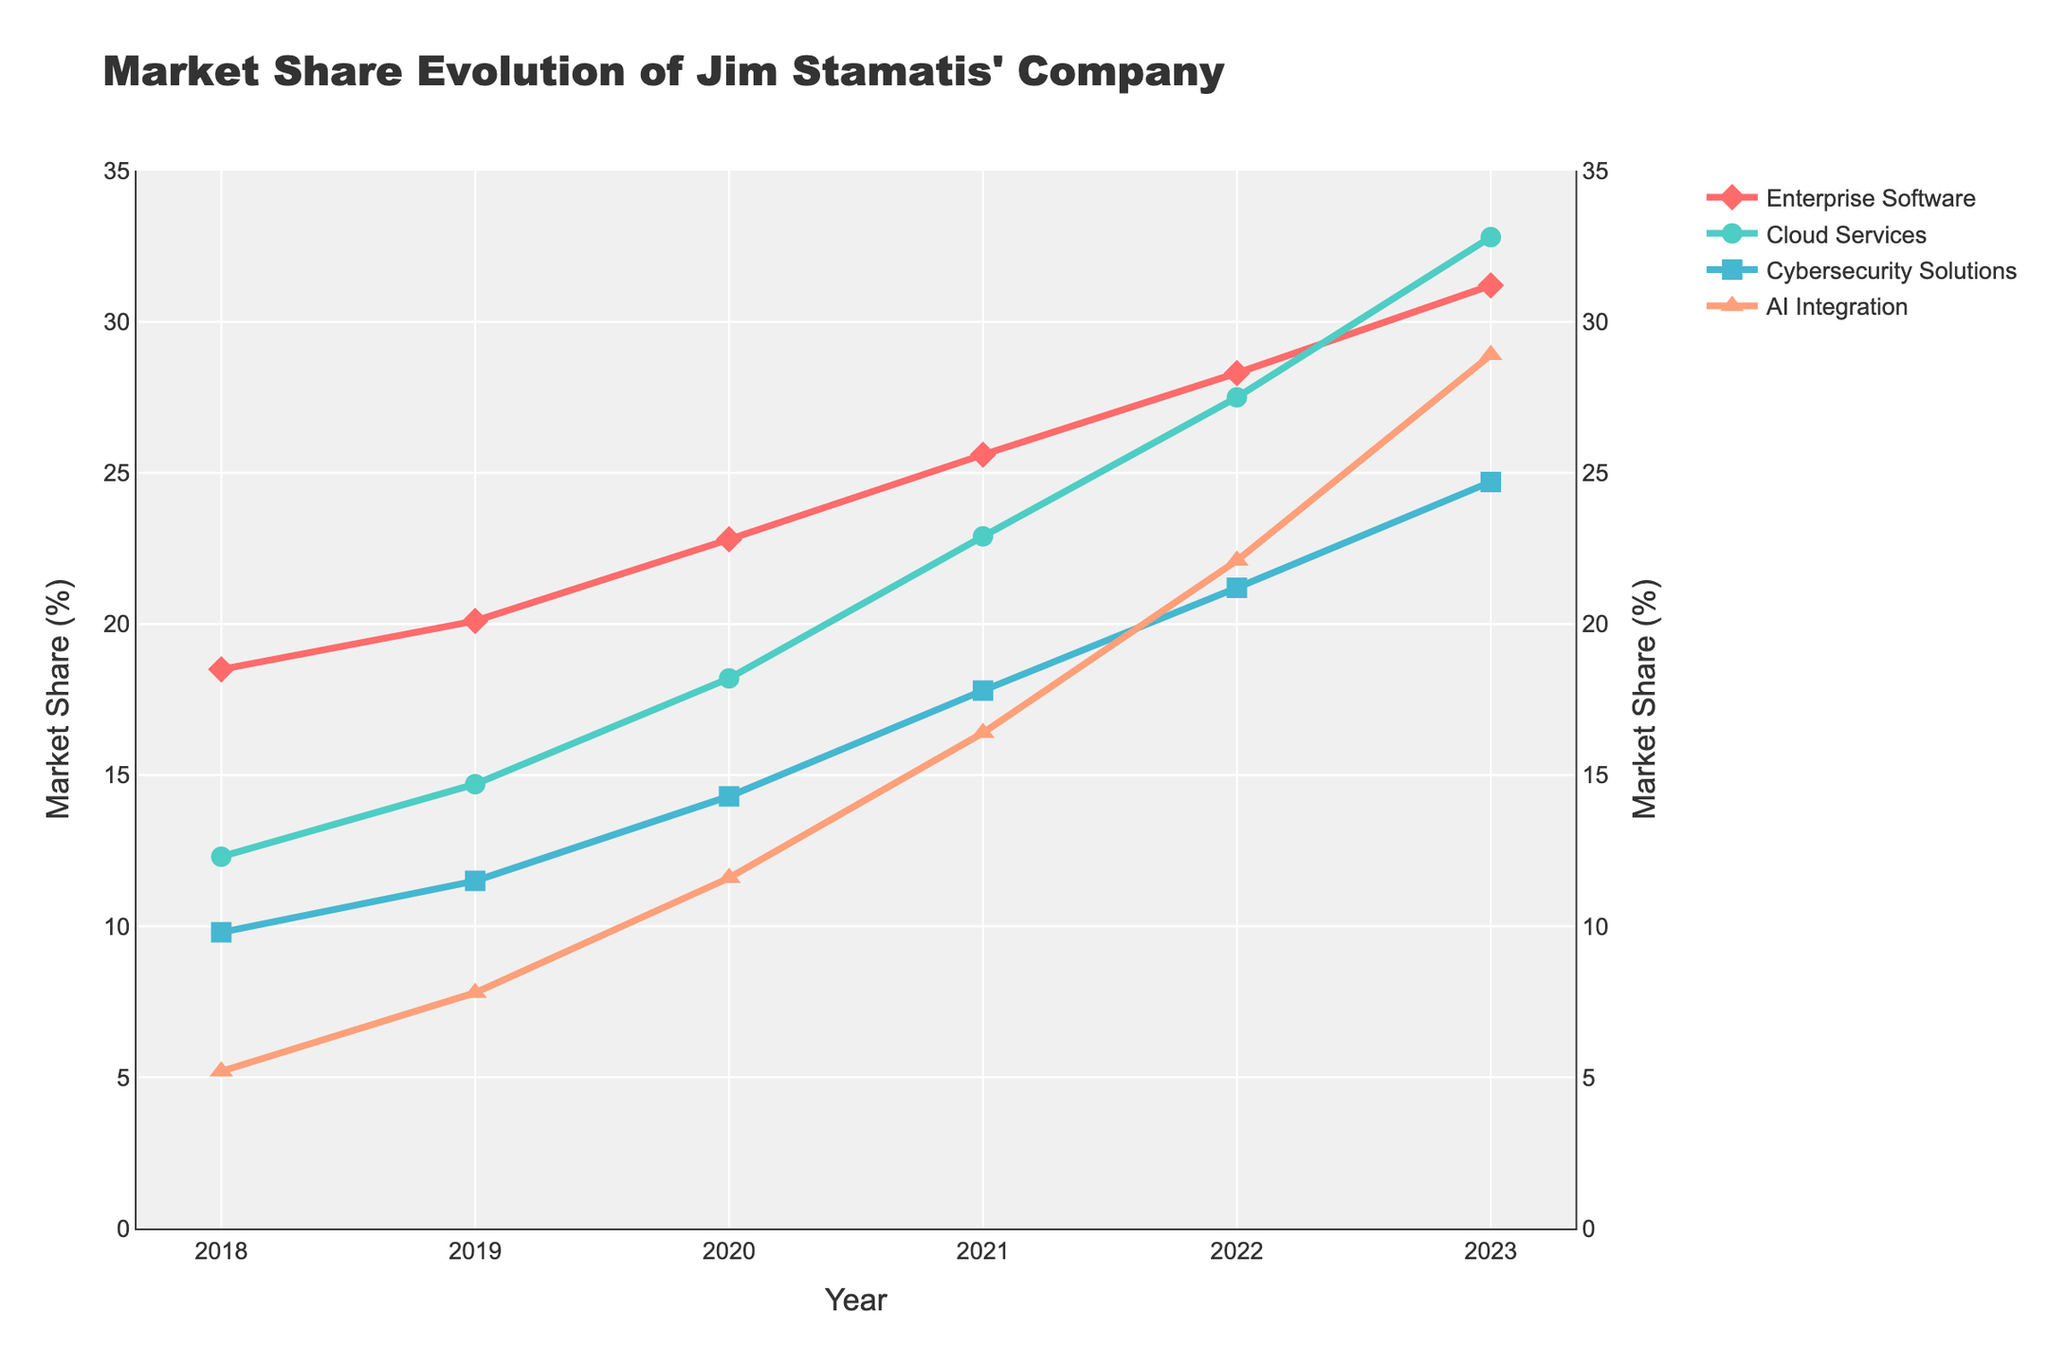what was the market share for Cloud Services in 2019 Refer to the point on the green line corresponding to the year 2019. The y-axis value at this point is the market share.
Answer: 14.7% which product category saw the highest market share increase between 2018 and 2023 Compare the market share of each product category in 2018 and 2023. AI Integration increased from 5.2% to 28.9%, a rise of 23.7%, the largest increase.
Answer: AI Integration how does the market share trend of Cybersecurity Solutions compare to AI Integration over the years Refer to the yellow and blue lines. Both categories show an upward trend, but AI Integration achieves a steep increase, surpassing Cybersecurity Solutions in market share by 2021.
Answer: AI Integration surpasses Cybersecurity Solutions in which year did Enterprise Software have a market share greater than 25% Check the red line graph. The market share exceeds 25% starting from the year 2021 and continues to increase thereafter.
Answer: 2021 what is the difference in market share between Cybersecurity Solutions in 2020 and AI Integration in 2020 Locate the y-axis values for Cybersecurity Solutions and AI Integration in 2020. Subtract AI Integration’s market share (11.6%) from Cybersecurity Solutions’ market share (14.3%).
Answer: 2.7% which product had the smallest market share in 2018 and by how much did it grow by 2023 Look at the values for all product categories in 2018. AI Integration had the smallest market share at 5.2%. In 2023, its market share grew to 28.9%.
Answer: AI Integration, 23.7% what is the market share of AI Integration in 2021 and how does it compare to Enterprise Software in the same year Check the y-axis values for AI Integration and Enterprise Software in 2021. AI Integration had 16.4%, while Enterprise Software had 25.6%.
Answer: AI Integration is 9.2% less than Enterprise Software in which year did Cloud Services surpass 25% market share, and how did it compare to Enterprise Software’s share in that year Identify the year when Cloud Services (the green line) exceeded 25%. This happens in 2022 with 27.5%. In the same year, Enterprise Software was at 28.3%.
Answer: 2022, slightly less than Enterprise Software what visual elements indicate AI Integration's rapid growth The orange line for AI Integration is the steepest, with triangle-up markers, indicating rapid growth.
Answer: Steep orange line, triangle-up markers when did the gap between Enterprise Software and Cybersecurity Solutions begin to widen significantly Compare the trajectories of the red and blue lines. The most noticeable widening occurs from 2020 onwards.
Answer: 2020 